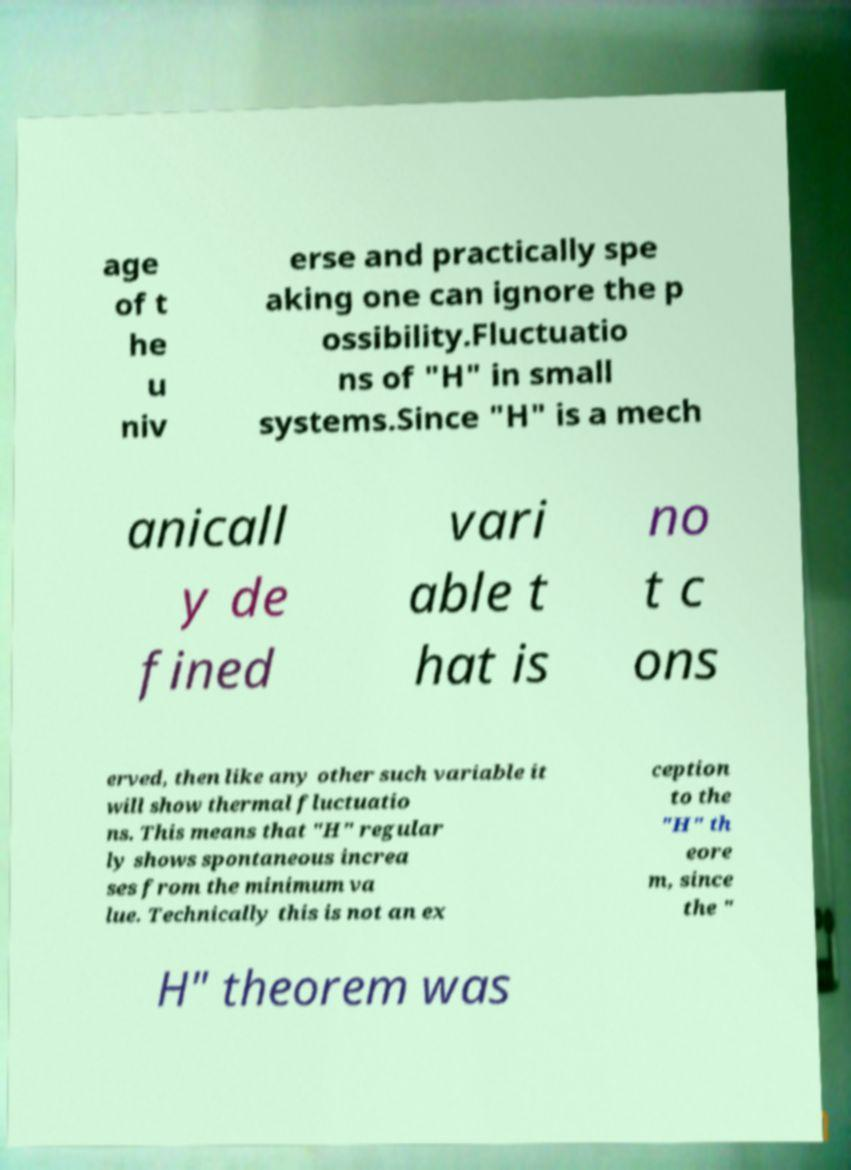Please read and relay the text visible in this image. What does it say? age of t he u niv erse and practically spe aking one can ignore the p ossibility.Fluctuatio ns of "H" in small systems.Since "H" is a mech anicall y de fined vari able t hat is no t c ons erved, then like any other such variable it will show thermal fluctuatio ns. This means that "H" regular ly shows spontaneous increa ses from the minimum va lue. Technically this is not an ex ception to the "H" th eore m, since the " H" theorem was 